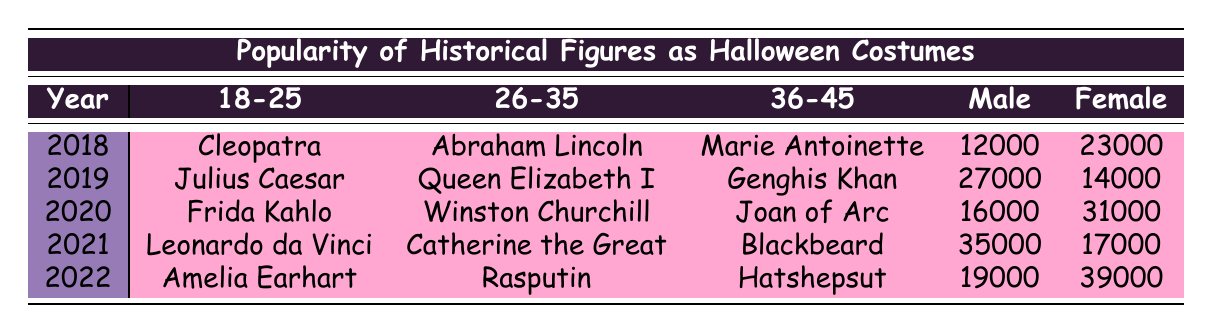What historical figure had the highest costume sales in 2021? In 2021, the data shows that Leonardo da Vinci had the highest costume sales at 22,000, which is compared to other figures in the same year.
Answer: Leonardo da Vinci Which age group had the highest costume sales of Frida Kahlo? In 2020, Frida Kahlo had 20,000 costume sales, which belong to the age group 18-25, indicating this specific age group was the only one associated with her character in that year.
Answer: 18-25 True or False: Joan of Arc was the most popular costume among the 36-45 age group in 2020. According to the data, Joan of Arc had 11,000 sales, while Marie Antoinette (8,000) was in 2018 and represents a different year. So, she is not the most popular for the specified age group for the given year.
Answer: False What is the total number of costume sales for Amelia Earhart from 2018 to 2022? Amelia Earhart only appears in 2022 with 25,000, and there are no records for her in previous years, resulting in her total sales being simply that amount for 2022.
Answer: 25,000 Which female historical figure had higher costume sales: Cleopatra or Catherine the Great? Cleopatra in 2018 had sales of 15,000, and Catherine the Great in 2021 had 17,000. Comparing the numbers, Catherine the Great had higher sales than Cleopatra.
Answer: Catherine the Great What is the average number of costume sales for male historical figures from 2018 to 2022? The data shows sales for males: 12,000 (2018), 18,000 (2019), 16,000 (2020), 22,000 (2021), and 19,000 (2022). Summing these values gives 85,000, and then dividing by 5 (the number of years) gives an average of 17,000.
Answer: 17,000 In how many years did the sales for Queen Elizabeth I reach above 12,000? The data shows that Queen Elizabeth I had sales of 14,000 in 2019, reaching above 12,000 only that once.
Answer: 1 year Which age group had increased popularity in historical figure costume sales from 2019 to 2020? In 2019, the 18-25 age group had 18,000 (Julius Caesar), while in 2020, they increased to 20,000 (Frida Kahlo), thus reflecting increased sales in that specific group.
Answer: 18-25 